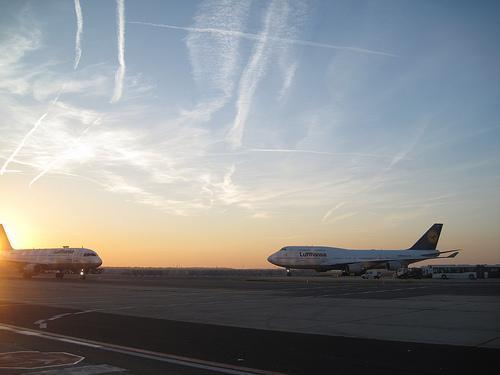How many airplanes are in the picture?
Give a very brief answer. 2. 